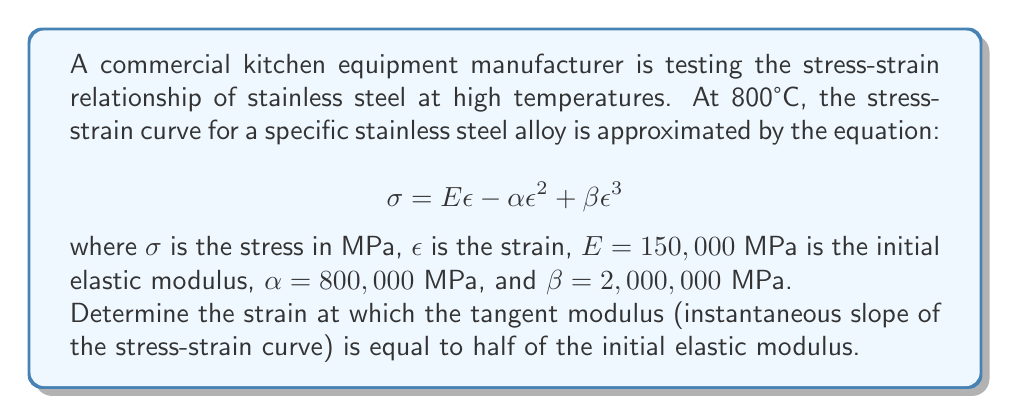Provide a solution to this math problem. To solve this problem, we need to follow these steps:

1) The tangent modulus is given by the first derivative of the stress-strain equation:

   $$\frac{d\sigma}{d\epsilon} = E - 2\alpha\epsilon + 3\beta\epsilon^2$$

2) We want to find the strain where this tangent modulus is equal to half of the initial elastic modulus:

   $$E - 2\alpha\epsilon + 3\beta\epsilon^2 = \frac{E}{2}$$

3) Substituting the given values:

   $$150,000 - 2(800,000)\epsilon + 3(2,000,000)\epsilon^2 = \frac{150,000}{2}$$

4) Simplifying:

   $$150,000 - 1,600,000\epsilon + 6,000,000\epsilon^2 = 75,000$$

5) Rearranging to standard quadratic form:

   $$6,000,000\epsilon^2 - 1,600,000\epsilon - 75,000 = 0$$

6) Dividing all terms by 75,000 to simplify:

   $$80\epsilon^2 - \frac{64}{3}\epsilon - 1 = 0$$

7) Using the quadratic formula, $\epsilon = \frac{-b \pm \sqrt{b^2 - 4ac}}{2a}$, where $a=80$, $b=-\frac{64}{3}$, and $c=-1$:

   $$\epsilon = \frac{\frac{64}{3} \pm \sqrt{(\frac{64}{3})^2 + 4(80)(1)}}{2(80)}$$

8) Simplifying:

   $$\epsilon = \frac{64 \pm \sqrt{4096 + 960}}{480} = \frac{64 \pm \sqrt{5056}}{480}$$

9) Calculating the positive root (as strain is typically positive):

   $$\epsilon = \frac{64 + \sqrt{5056}}{480} \approx 0.2764$$
Answer: $\epsilon \approx 0.2764$ 